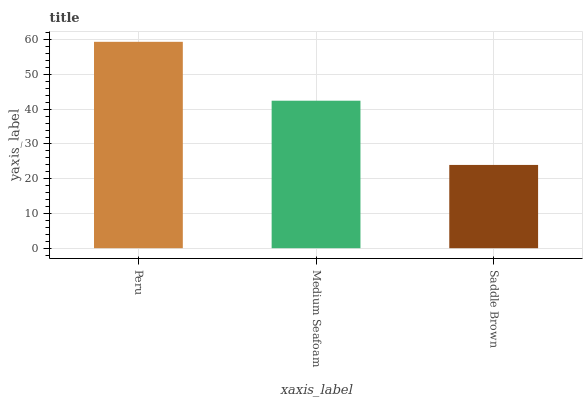Is Saddle Brown the minimum?
Answer yes or no. Yes. Is Peru the maximum?
Answer yes or no. Yes. Is Medium Seafoam the minimum?
Answer yes or no. No. Is Medium Seafoam the maximum?
Answer yes or no. No. Is Peru greater than Medium Seafoam?
Answer yes or no. Yes. Is Medium Seafoam less than Peru?
Answer yes or no. Yes. Is Medium Seafoam greater than Peru?
Answer yes or no. No. Is Peru less than Medium Seafoam?
Answer yes or no. No. Is Medium Seafoam the high median?
Answer yes or no. Yes. Is Medium Seafoam the low median?
Answer yes or no. Yes. Is Saddle Brown the high median?
Answer yes or no. No. Is Saddle Brown the low median?
Answer yes or no. No. 